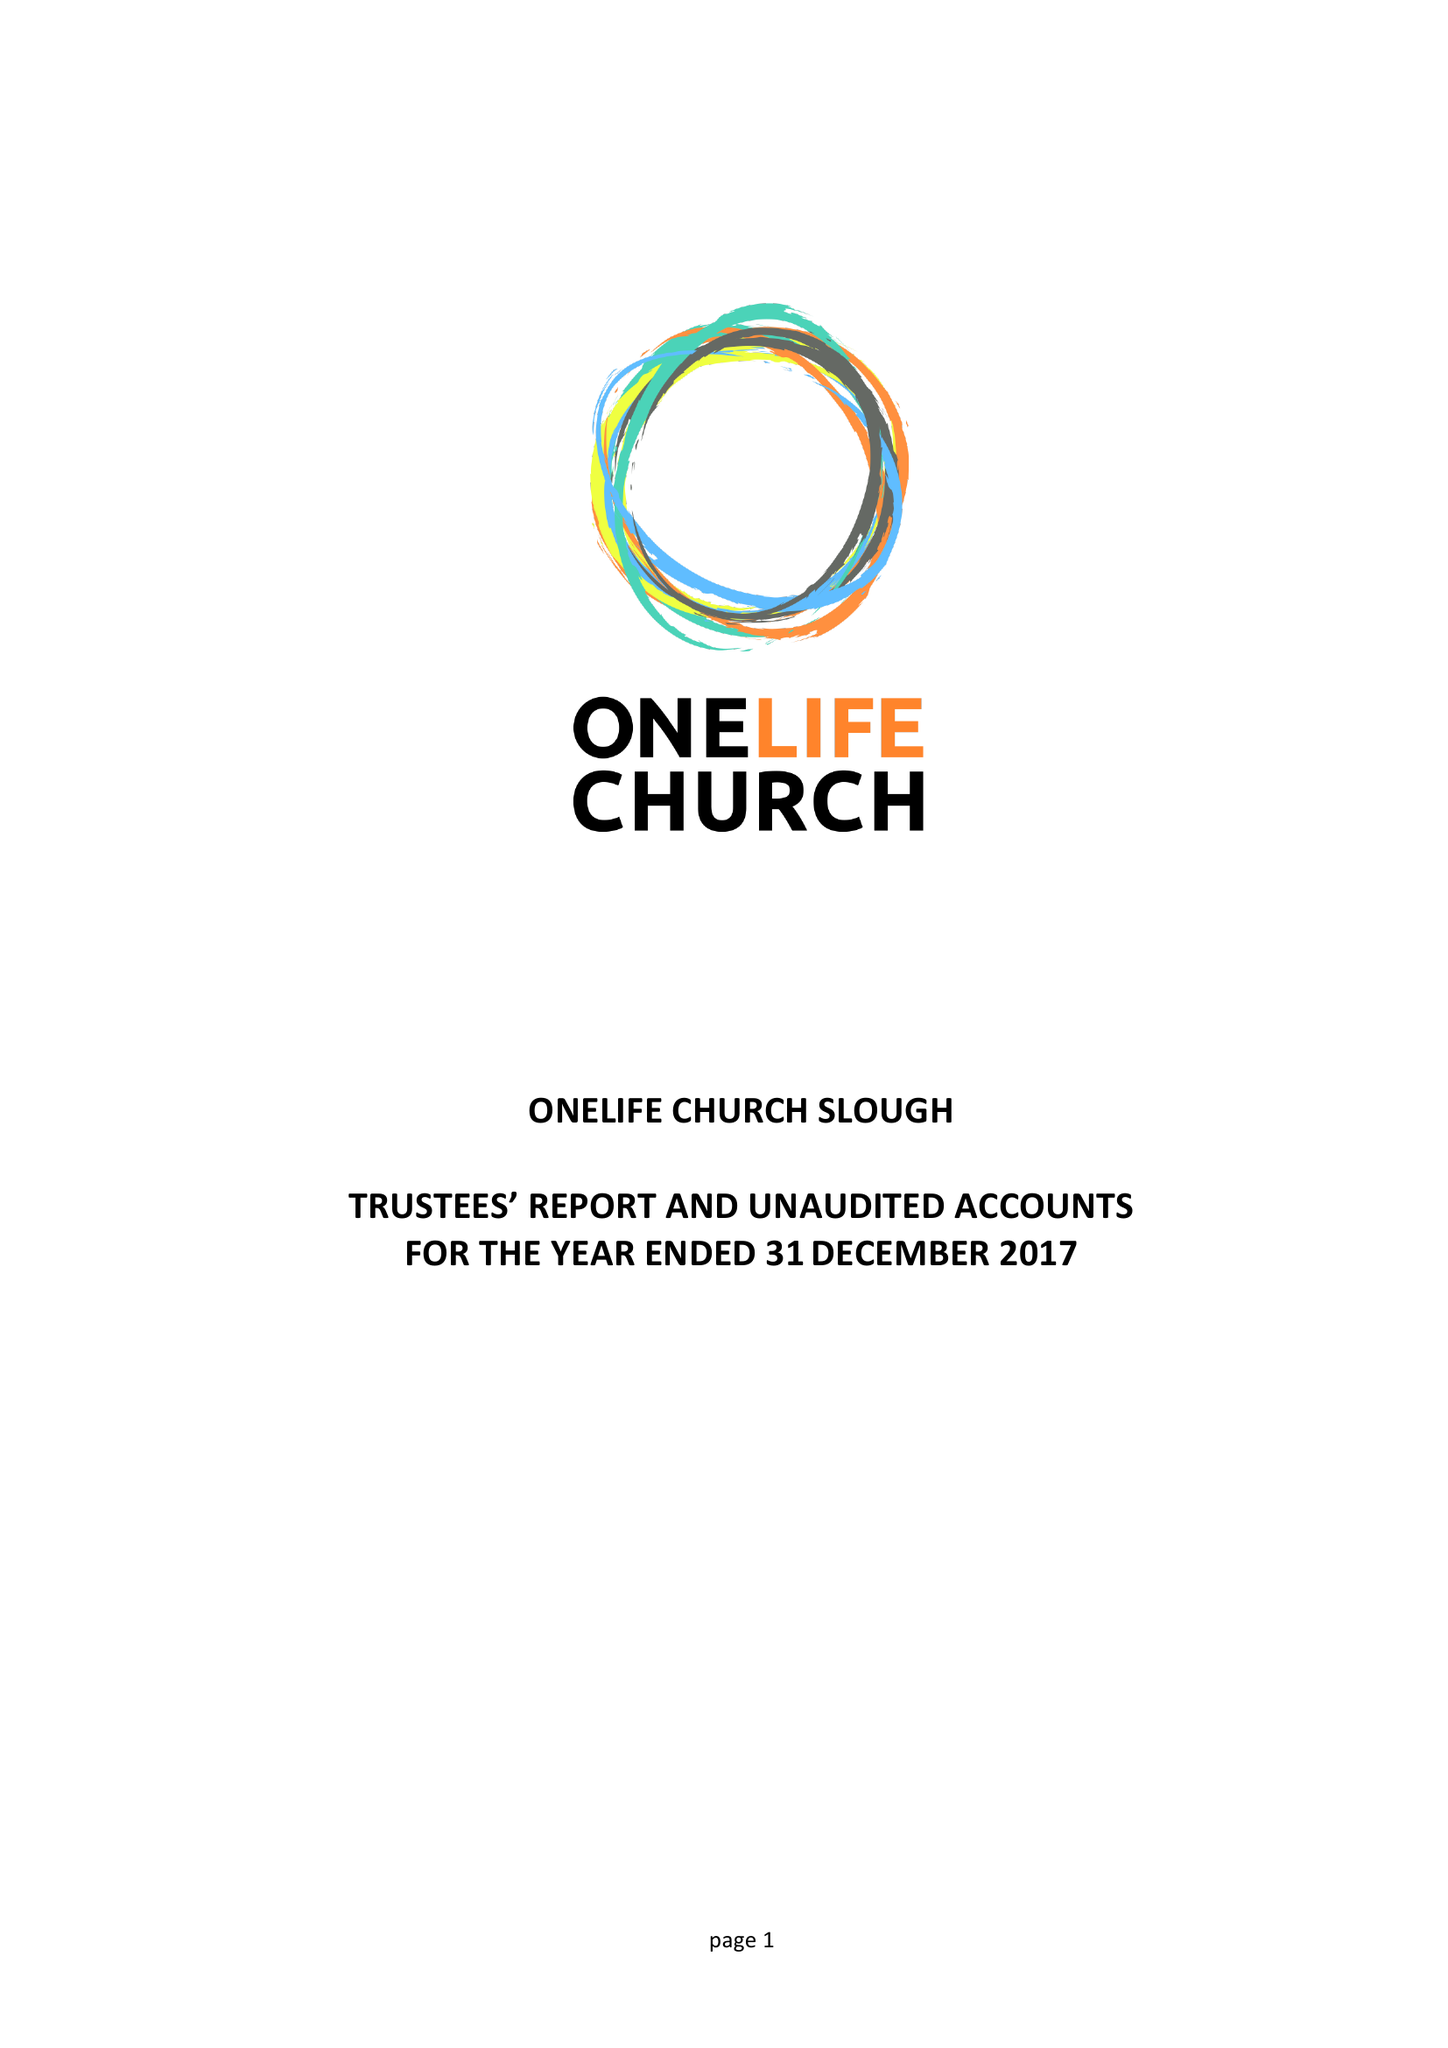What is the value for the address__post_town?
Answer the question using a single word or phrase. SLOUGH 